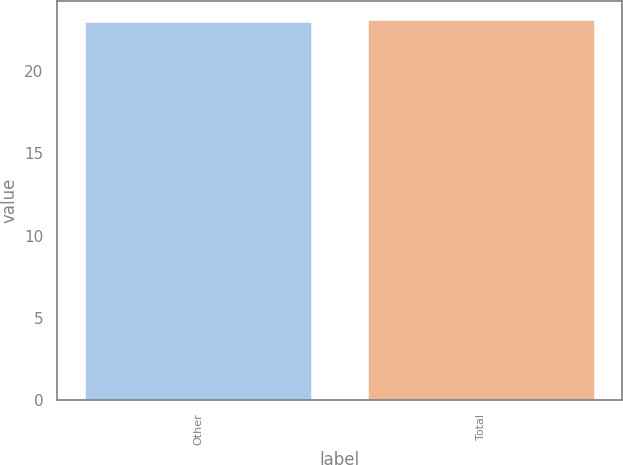Convert chart. <chart><loc_0><loc_0><loc_500><loc_500><bar_chart><fcel>Other<fcel>Total<nl><fcel>23<fcel>23.1<nl></chart> 